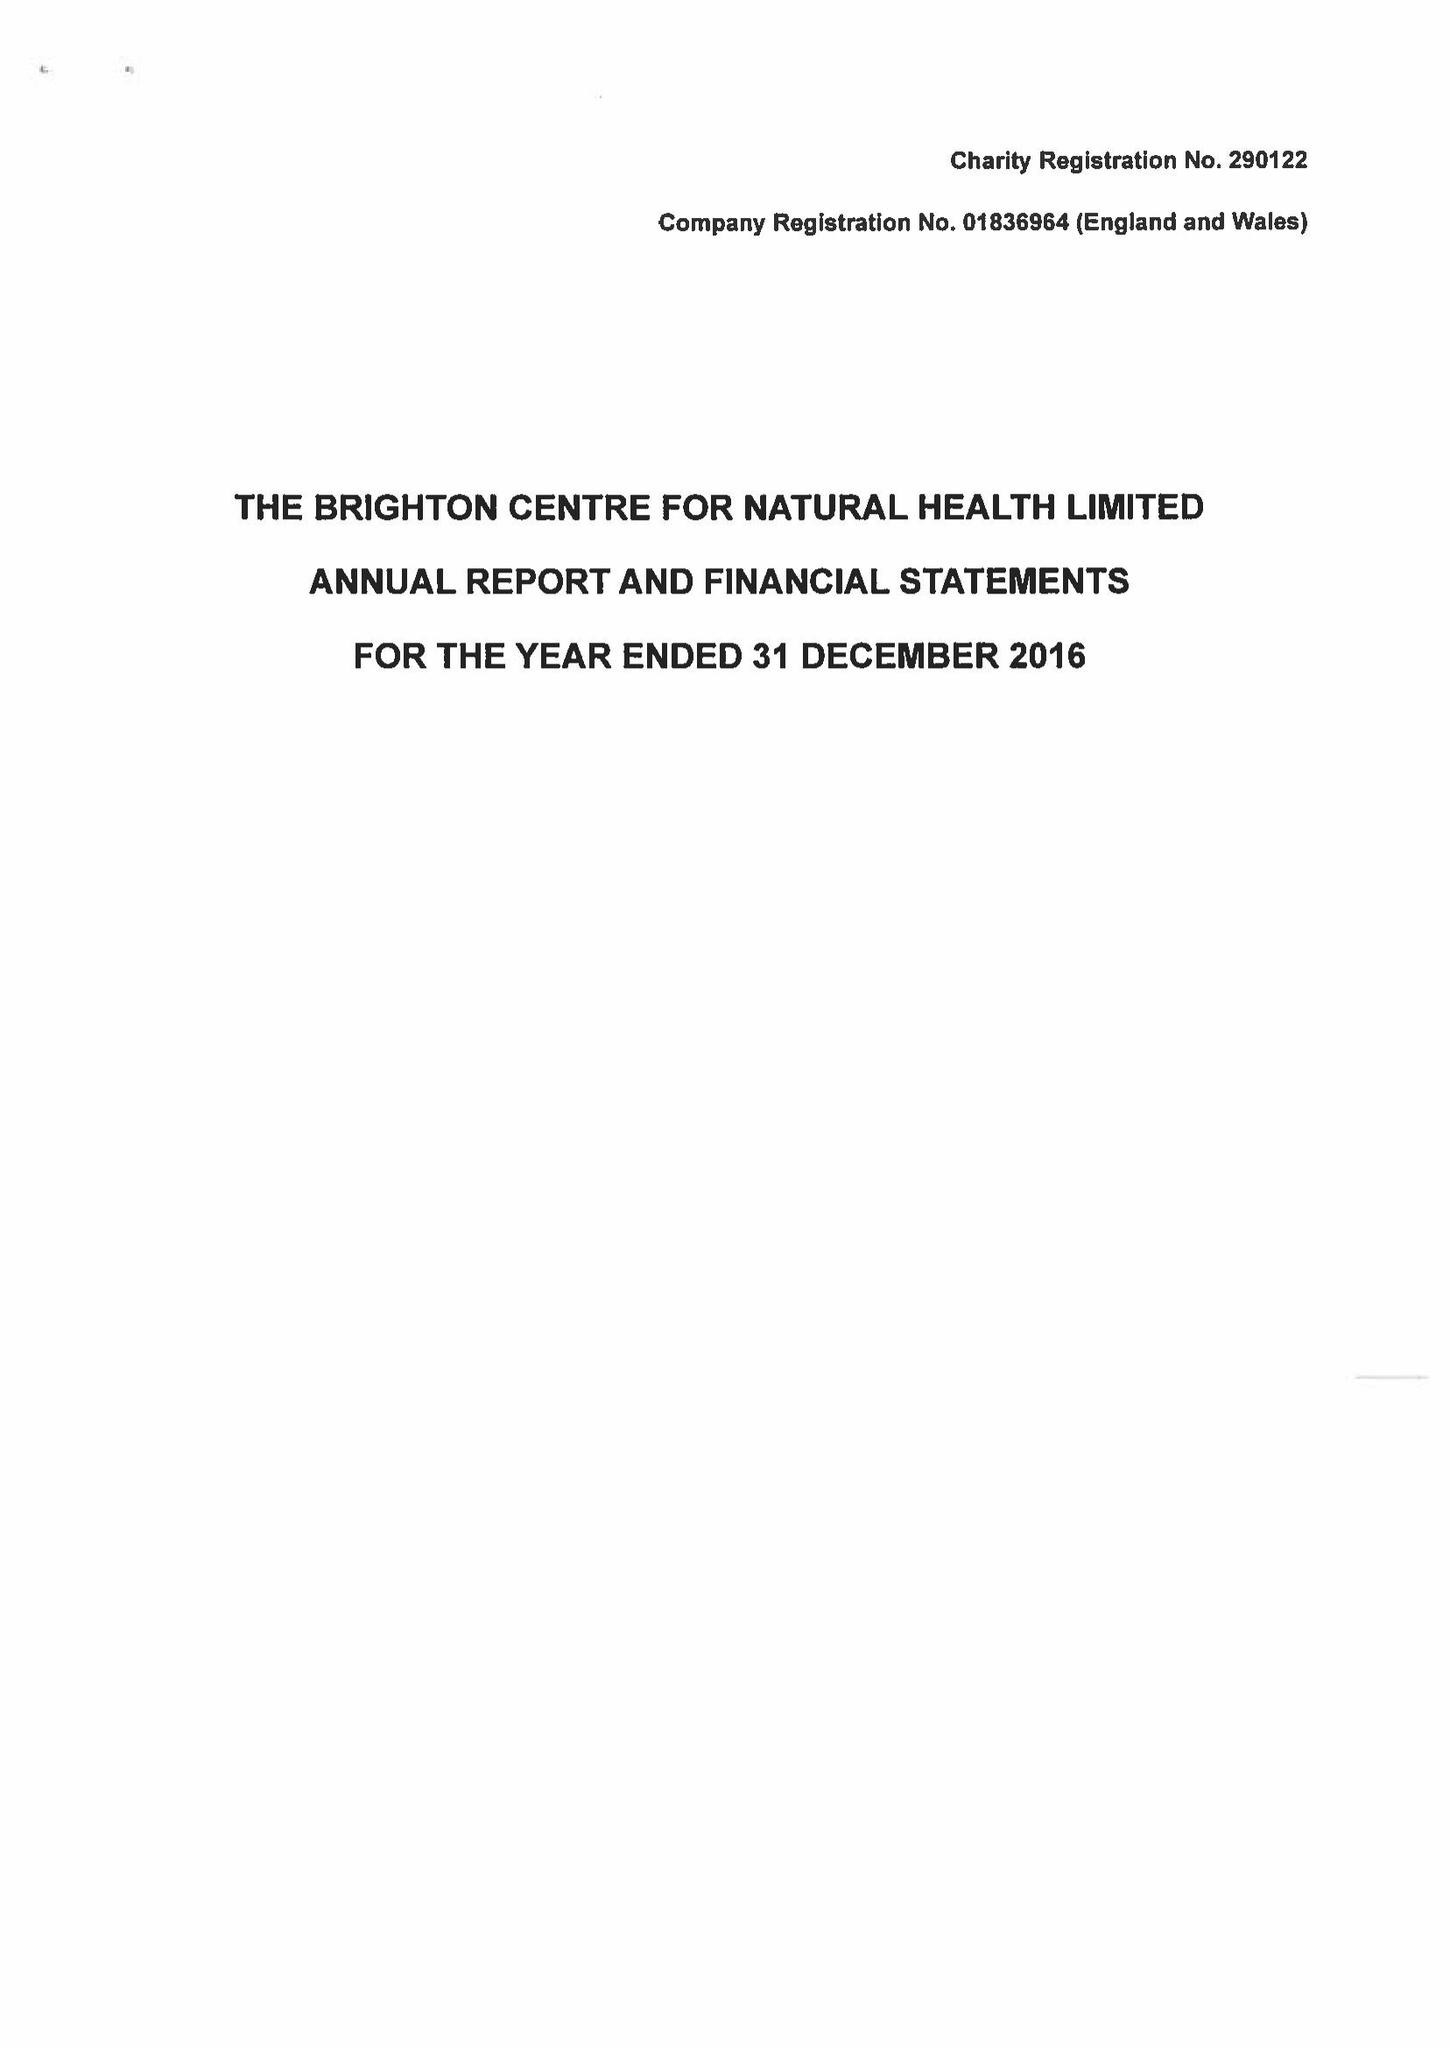What is the value for the spending_annually_in_british_pounds?
Answer the question using a single word or phrase. 229881.00 